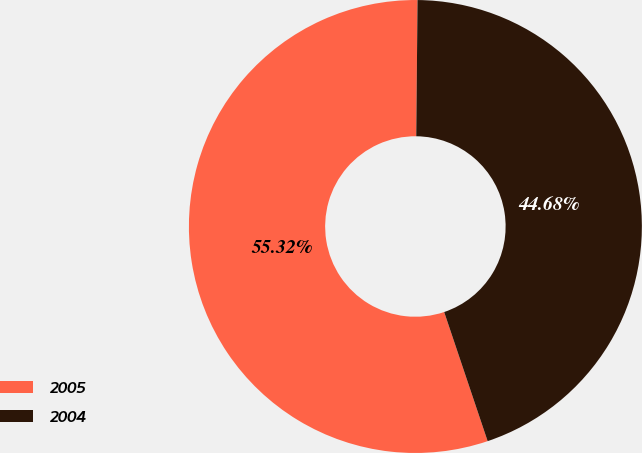Convert chart to OTSL. <chart><loc_0><loc_0><loc_500><loc_500><pie_chart><fcel>2005<fcel>2004<nl><fcel>55.32%<fcel>44.68%<nl></chart> 